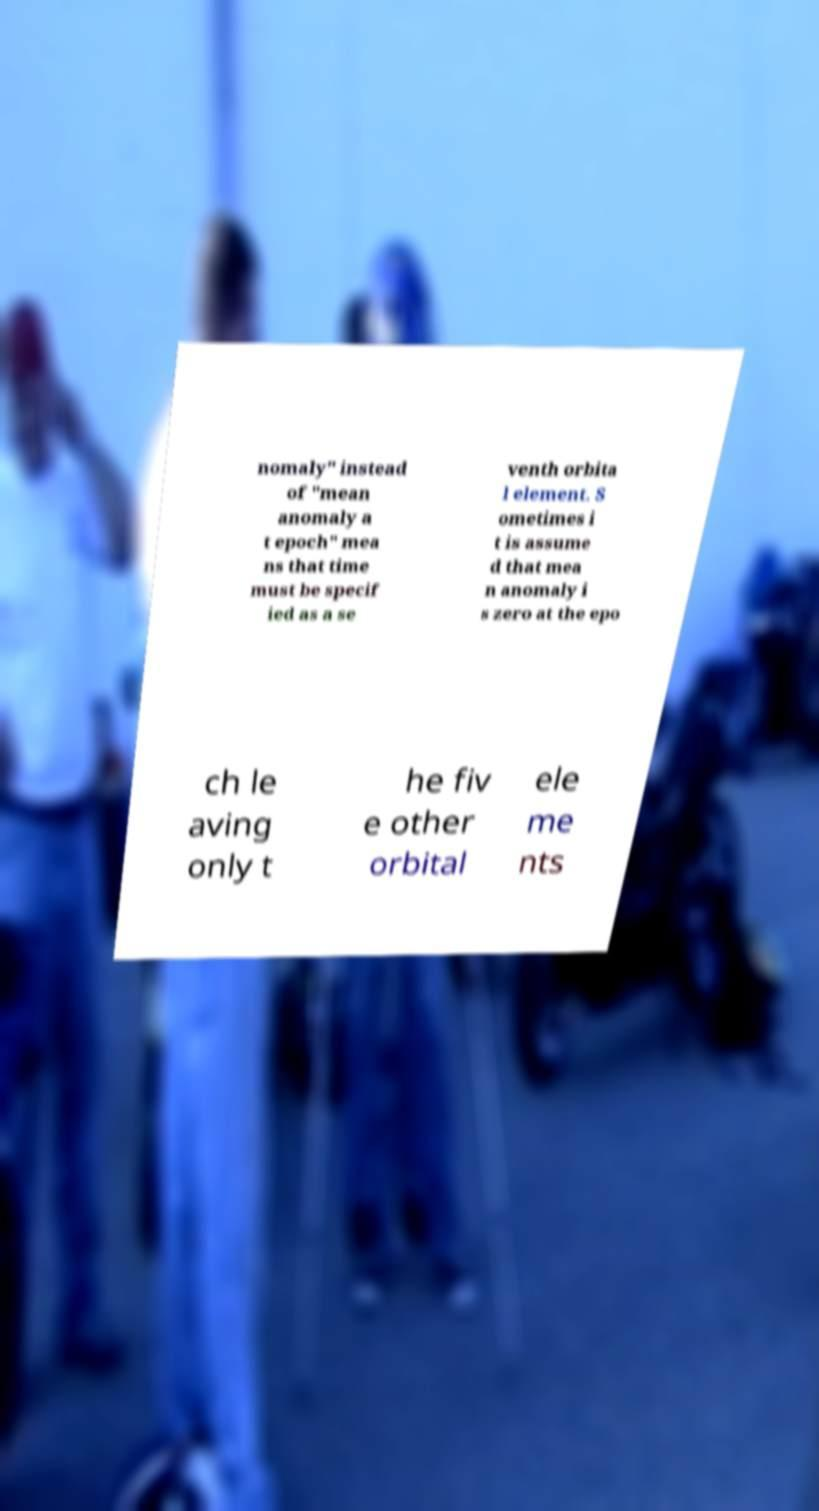Please identify and transcribe the text found in this image. nomaly" instead of "mean anomaly a t epoch" mea ns that time must be specif ied as a se venth orbita l element. S ometimes i t is assume d that mea n anomaly i s zero at the epo ch le aving only t he fiv e other orbital ele me nts 